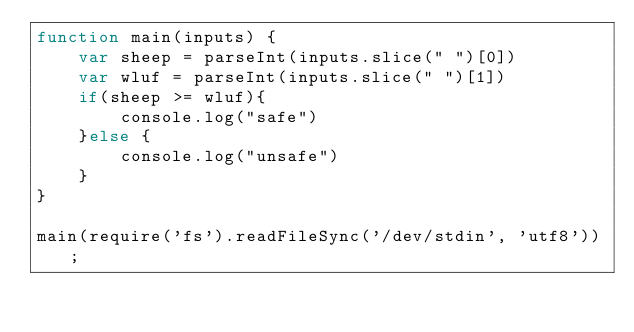Convert code to text. <code><loc_0><loc_0><loc_500><loc_500><_JavaScript_>function main(inputs) {
    var sheep = parseInt(inputs.slice(" ")[0])
    var wluf = parseInt(inputs.slice(" ")[1])
    if(sheep >= wluf){
        console.log("safe")
    }else {
        console.log("unsafe")
    }
}

main(require('fs').readFileSync('/dev/stdin', 'utf8'));</code> 